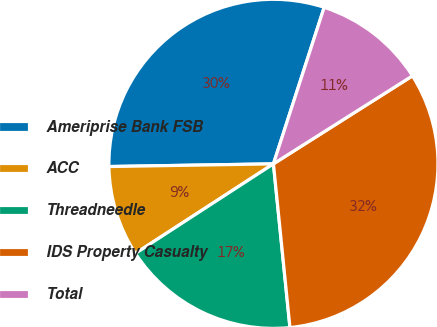Convert chart to OTSL. <chart><loc_0><loc_0><loc_500><loc_500><pie_chart><fcel>Ameriprise Bank FSB<fcel>ACC<fcel>Threadneedle<fcel>IDS Property Casualty<fcel>Total<nl><fcel>30.25%<fcel>8.9%<fcel>17.44%<fcel>32.38%<fcel>11.03%<nl></chart> 